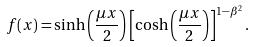<formula> <loc_0><loc_0><loc_500><loc_500>f ( x ) = \sinh { \left ( \frac { \mu x } { 2 } \right ) } \left [ \cosh { \left ( \frac { \mu x } { 2 } \right ) } \right ] ^ { 1 - \beta ^ { 2 } } .</formula> 